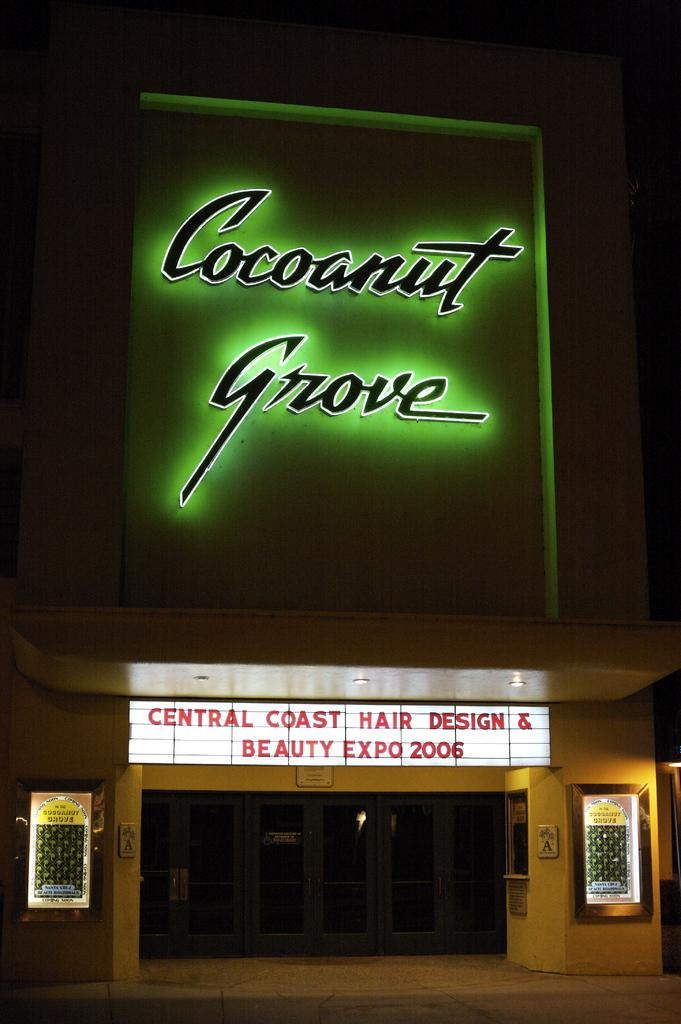What is the main structure in the image? There is a building in the image. What feature is prominently displayed on the building? There are many LED boards on the building. What color dominates the background of the image? The background of the image is black. What type of treatment is being offered to the customers in the image? There is no indication of any treatment being offered in the image, as it primarily features a building with LED boards. What is the value of the profit generated by the LED boards in the image? There is no information about the profit generated by the LED boards in the image, as it only shows the building and the boards themselves. 